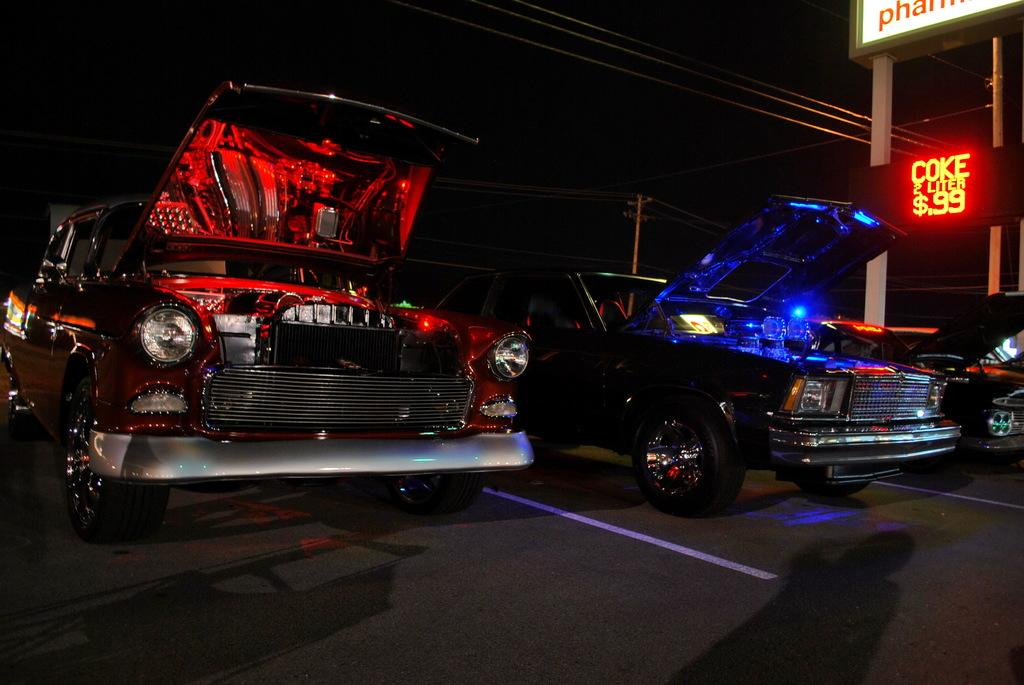What objects are on the floor in the image? There are motor vehicles on the floor in the image. What type of signs are present in the image? There are name boards in the image. What else can be seen in the image besides the motor vehicles and name boards? Cables are visible in the image. What type of dog can be seen playing a game in the image? There is no dog or game present in the image; it features motor vehicles, name boards, and cables. 